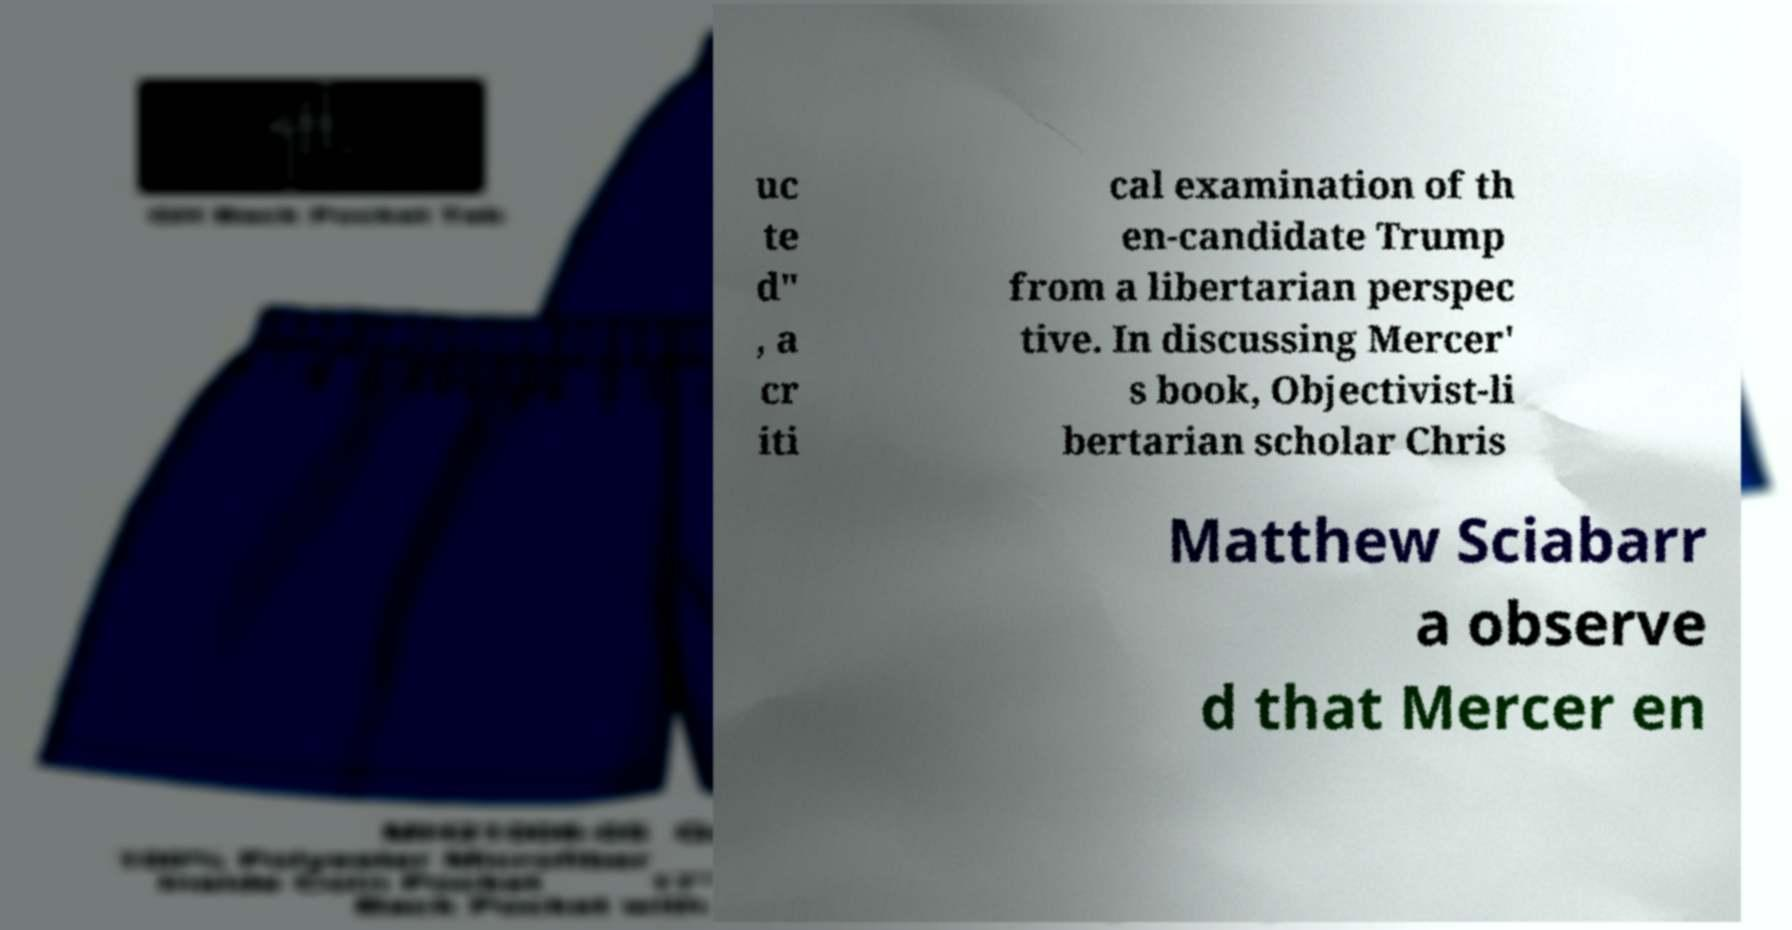What messages or text are displayed in this image? I need them in a readable, typed format. uc te d" , a cr iti cal examination of th en-candidate Trump from a libertarian perspec tive. In discussing Mercer' s book, Objectivist-li bertarian scholar Chris Matthew Sciabarr a observe d that Mercer en 